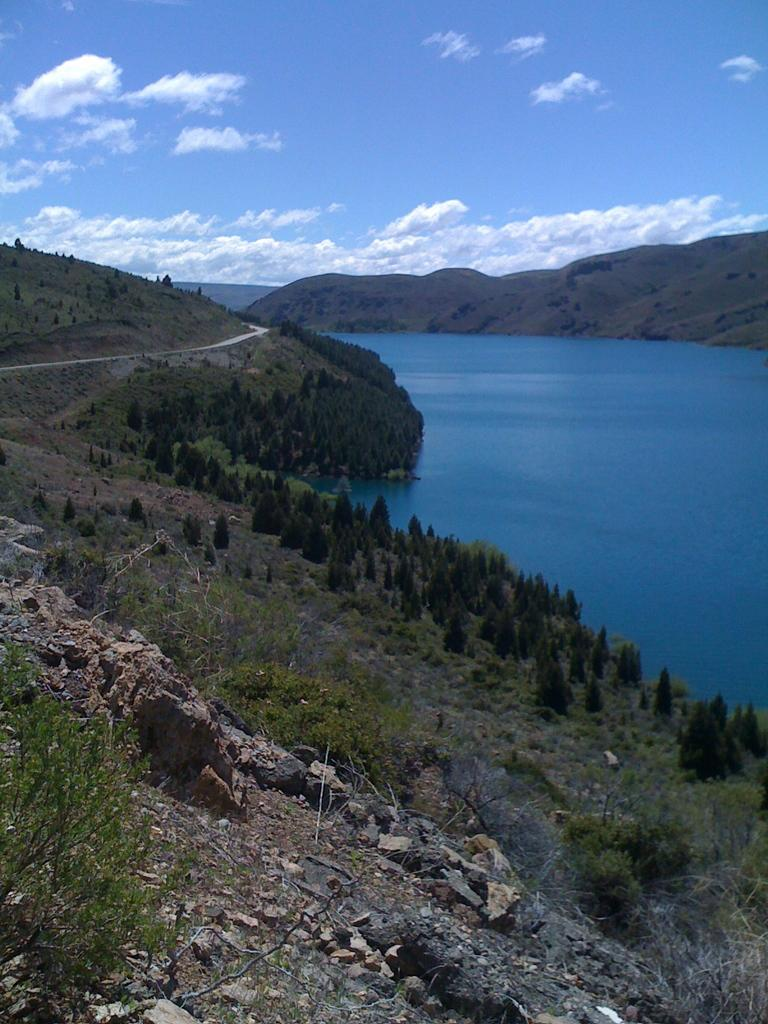What type of surface can be seen in the image? There is ground visible in the image. What type of vegetation is present on the ground? There is grass on the ground. What other natural elements can be seen in the image? There is a rock, plants, trees, water, and mountains visible in the image. What is visible in the sky? The sky is visible in the image, and there are clouds present. What type of liquid is being poured from the clouds in the image? There is no liquid being poured from the clouds in the image; the clouds are simply visible in the sky. What part of the body is sneezing in the image? There is no sneezing or any body parts visible in the image. 